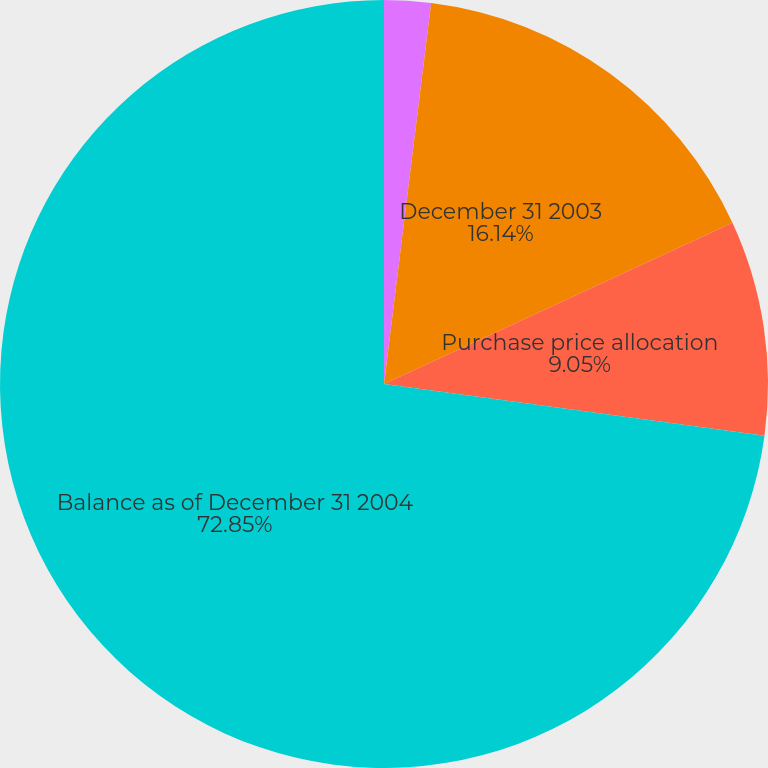<chart> <loc_0><loc_0><loc_500><loc_500><pie_chart><fcel>Acquisitions<fcel>December 31 2003<fcel>Purchase price allocation<fcel>Balance as of December 31 2004<nl><fcel>1.96%<fcel>16.14%<fcel>9.05%<fcel>72.86%<nl></chart> 